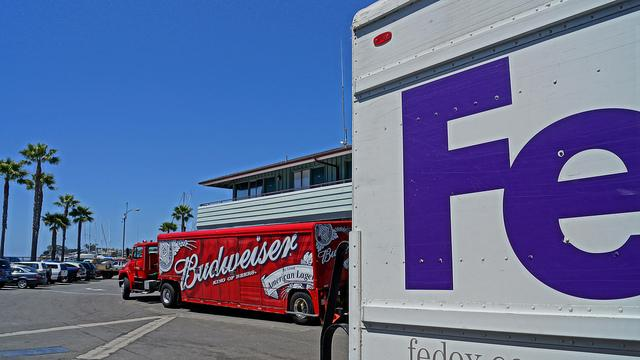What service does the vehicle with the purple letters provide?

Choices:
A) deliveries
B) groceries
C) alcohol
D) security deliveries 